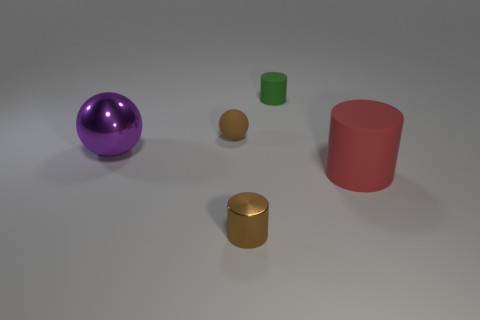Subtract all red cylinders. How many cylinders are left? 2 Add 1 brown metal things. How many objects exist? 6 Subtract all green cylinders. How many cylinders are left? 2 Subtract 1 spheres. How many spheres are left? 1 Subtract all cylinders. How many objects are left? 2 Subtract all blue balls. Subtract all cyan cylinders. How many balls are left? 2 Subtract all small green things. Subtract all purple balls. How many objects are left? 3 Add 4 small objects. How many small objects are left? 7 Add 1 purple metallic spheres. How many purple metallic spheres exist? 2 Subtract 0 cyan cylinders. How many objects are left? 5 